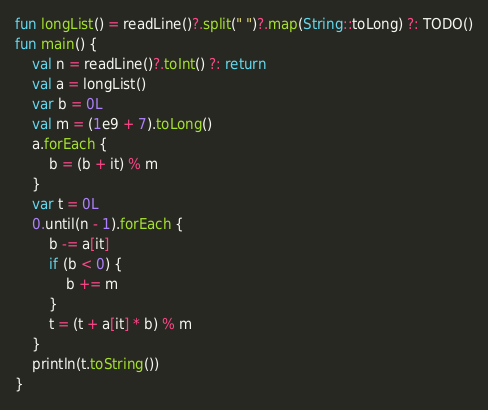<code> <loc_0><loc_0><loc_500><loc_500><_Kotlin_>fun longList() = readLine()?.split(" ")?.map(String::toLong) ?: TODO()
fun main() {
    val n = readLine()?.toInt() ?: return
    val a = longList()
    var b = 0L
    val m = (1e9 + 7).toLong()
    a.forEach {
        b = (b + it) % m
    }
    var t = 0L
    0.until(n - 1).forEach {
        b -= a[it]
        if (b < 0) {
            b += m
        }
        t = (t + a[it] * b) % m
    }
    println(t.toString())
}</code> 